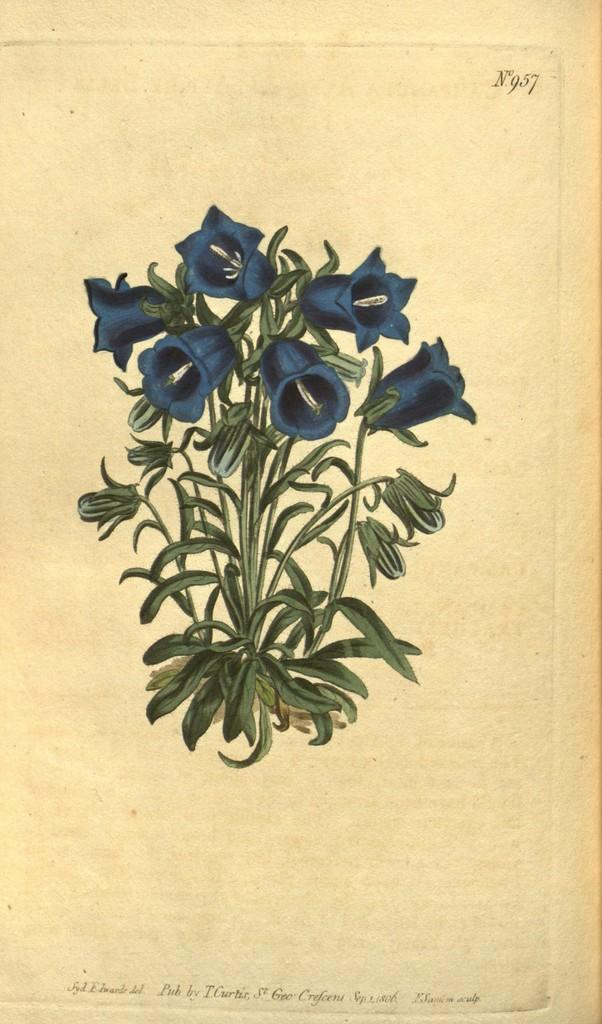What is the main subject of the image? There is a painting in the image. What does the painting depict? The painting depicts a plant. What specific feature of the plant can be observed in the painting? The plant has flowers. Who are the actors in the painting, and what play are they performing? There are no actors or plays depicted in the painting; it features a plant with flowers. 